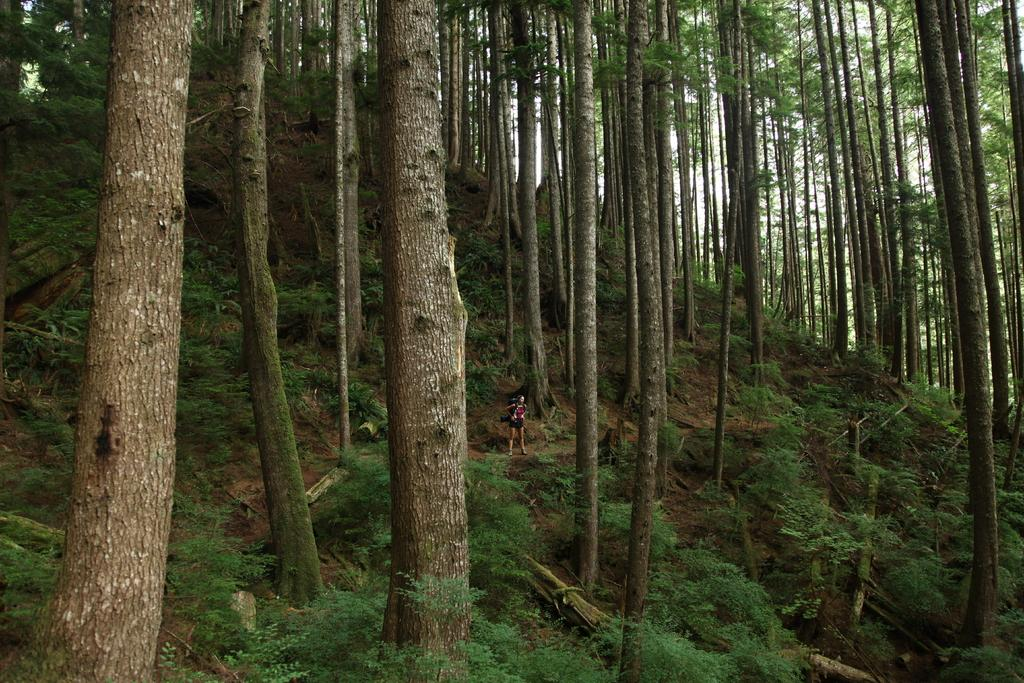What type of natural elements can be seen in the image? There are trees and plants in the image. Can you describe the landscape in the image? The image appears to depict a hill. Is there any human presence in the image? Yes, there is a person standing in the image. How many dogs are playing with balls at the bottom of the hill in the image? There are no dogs or balls present in the image; it only features trees, plants, a hill, and a person. 